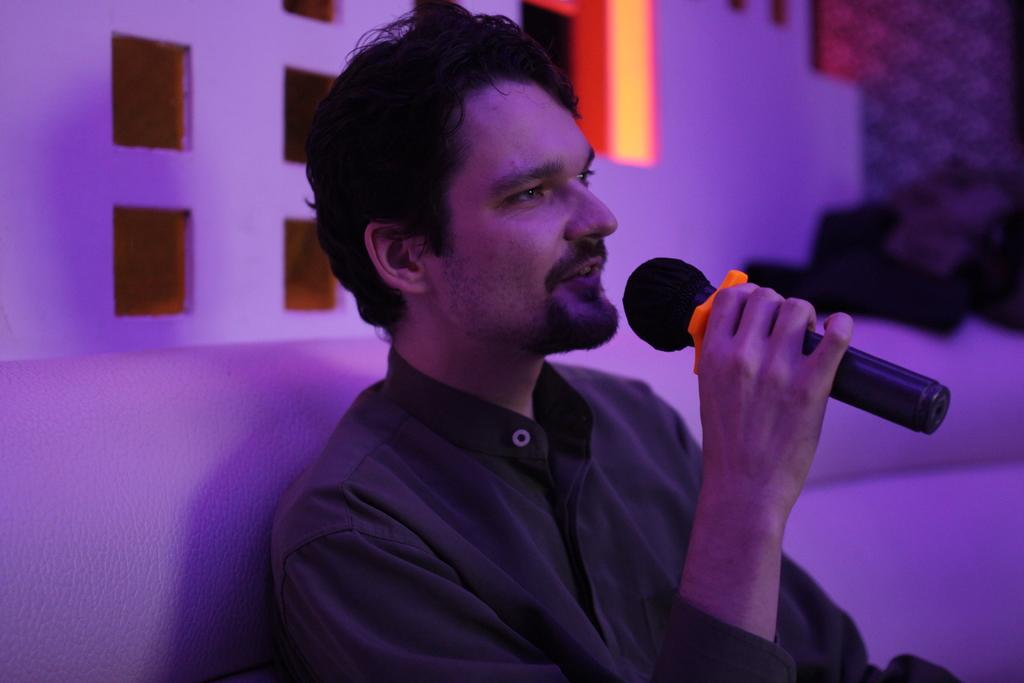What is the person in the image doing? The person is holding a microphone in his hand. What is the person wearing in the image? The person is wearing a black shirt. What is the person sitting on in the image? The person is sitting on a sofa. What can be seen behind the person in the image? There is a wall behind the person. How much income does the person earn from using the pail in the image? There is no pail present in the image, and therefore no income can be earned from using it. 